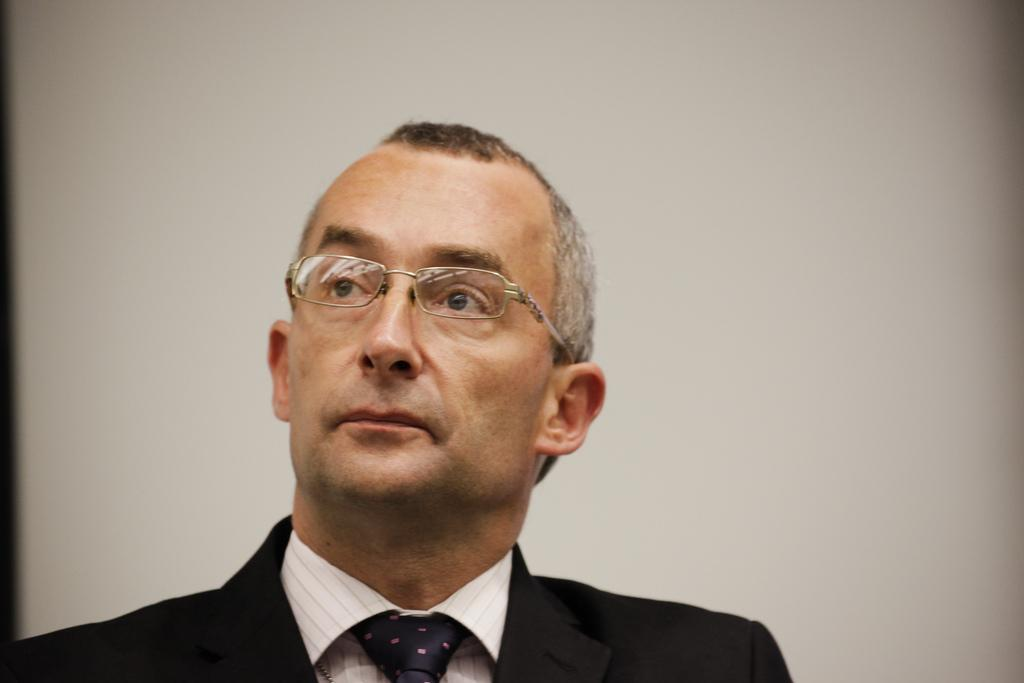Who is present in the image? There is a man in the image. What is the man wearing? The man is wearing a suit. What can be seen in the background of the image? There is a well in the background of the image. Is the secretary in the image whispering quietly to the insect? There is no secretary or insect present in the image. 